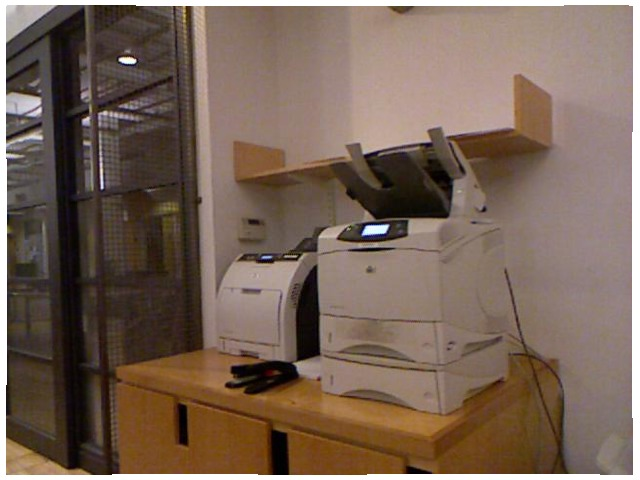<image>
Can you confirm if the desk is under the stapler? Yes. The desk is positioned underneath the stapler, with the stapler above it in the vertical space. Where is the machine in relation to the table? Is it under the table? No. The machine is not positioned under the table. The vertical relationship between these objects is different. Is the printer to the right of the printer? Yes. From this viewpoint, the printer is positioned to the right side relative to the printer. Where is the stapler in relation to the copier? Is it to the left of the copier? No. The stapler is not to the left of the copier. From this viewpoint, they have a different horizontal relationship. Where is the wire in relation to the printer? Is it in the printer? Yes. The wire is contained within or inside the printer, showing a containment relationship. Is there a stapler in the drawer? No. The stapler is not contained within the drawer. These objects have a different spatial relationship. 